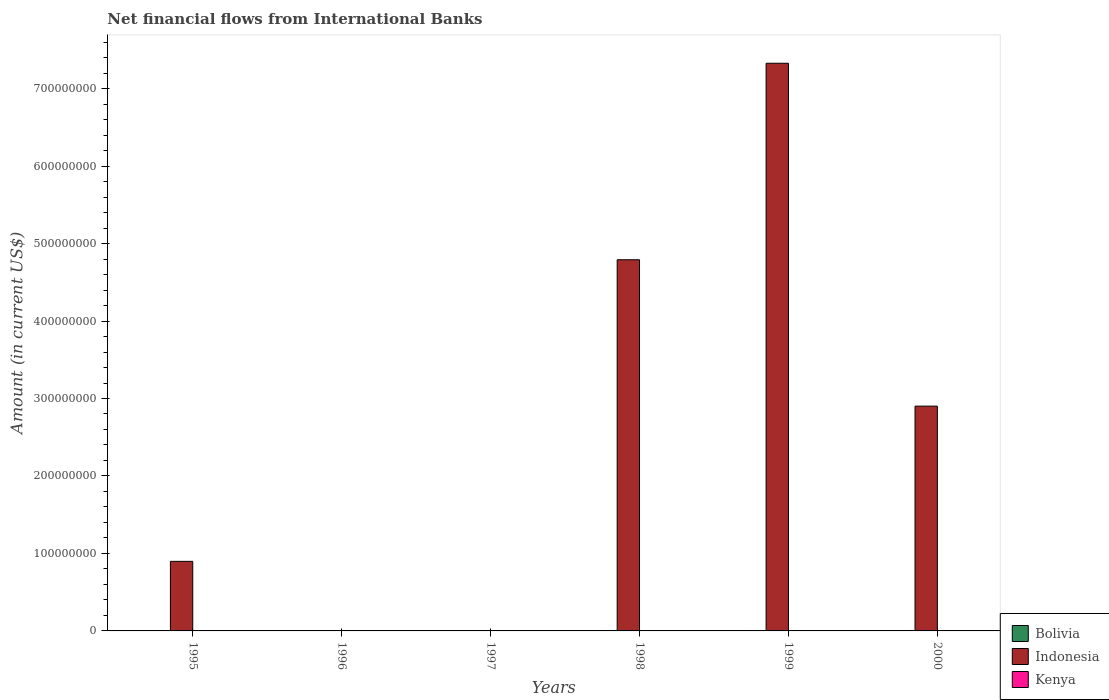How many different coloured bars are there?
Ensure brevity in your answer.  1. Are the number of bars on each tick of the X-axis equal?
Offer a very short reply. No. How many bars are there on the 5th tick from the left?
Your answer should be very brief. 1. How many bars are there on the 5th tick from the right?
Your answer should be compact. 0. Across all years, what is the maximum net financial aid flows in Indonesia?
Ensure brevity in your answer.  7.33e+08. In which year was the net financial aid flows in Indonesia maximum?
Your answer should be compact. 1999. What is the total net financial aid flows in Indonesia in the graph?
Make the answer very short. 1.59e+09. What is the difference between the net financial aid flows in Indonesia in 1998 and that in 1999?
Give a very brief answer. -2.54e+08. What is the difference between the net financial aid flows in Bolivia in 1999 and the net financial aid flows in Indonesia in 1995?
Provide a short and direct response. -8.98e+07. What is the average net financial aid flows in Indonesia per year?
Your response must be concise. 2.65e+08. In how many years, is the net financial aid flows in Indonesia greater than 540000000 US$?
Offer a very short reply. 1. What is the ratio of the net financial aid flows in Indonesia in 1995 to that in 2000?
Ensure brevity in your answer.  0.31. Is the net financial aid flows in Indonesia in 1998 less than that in 1999?
Keep it short and to the point. Yes. What is the difference between the highest and the second highest net financial aid flows in Indonesia?
Keep it short and to the point. 2.54e+08. What is the difference between the highest and the lowest net financial aid flows in Indonesia?
Ensure brevity in your answer.  7.33e+08. In how many years, is the net financial aid flows in Kenya greater than the average net financial aid flows in Kenya taken over all years?
Offer a terse response. 0. Are all the bars in the graph horizontal?
Provide a succinct answer. No. How many years are there in the graph?
Offer a very short reply. 6. Does the graph contain grids?
Ensure brevity in your answer.  No. What is the title of the graph?
Your answer should be compact. Net financial flows from International Banks. What is the label or title of the X-axis?
Your answer should be very brief. Years. What is the Amount (in current US$) in Indonesia in 1995?
Ensure brevity in your answer.  8.98e+07. What is the Amount (in current US$) of Kenya in 1995?
Provide a succinct answer. 0. What is the Amount (in current US$) of Bolivia in 1996?
Give a very brief answer. 0. What is the Amount (in current US$) of Indonesia in 1997?
Keep it short and to the point. 0. What is the Amount (in current US$) in Kenya in 1997?
Provide a short and direct response. 0. What is the Amount (in current US$) in Bolivia in 1998?
Offer a terse response. 0. What is the Amount (in current US$) of Indonesia in 1998?
Give a very brief answer. 4.79e+08. What is the Amount (in current US$) in Kenya in 1998?
Your answer should be very brief. 0. What is the Amount (in current US$) of Bolivia in 1999?
Give a very brief answer. 0. What is the Amount (in current US$) of Indonesia in 1999?
Your answer should be very brief. 7.33e+08. What is the Amount (in current US$) of Kenya in 1999?
Provide a succinct answer. 0. What is the Amount (in current US$) of Indonesia in 2000?
Your answer should be compact. 2.90e+08. What is the Amount (in current US$) in Kenya in 2000?
Keep it short and to the point. 0. Across all years, what is the maximum Amount (in current US$) in Indonesia?
Your response must be concise. 7.33e+08. What is the total Amount (in current US$) of Bolivia in the graph?
Give a very brief answer. 0. What is the total Amount (in current US$) of Indonesia in the graph?
Provide a short and direct response. 1.59e+09. What is the total Amount (in current US$) in Kenya in the graph?
Offer a terse response. 0. What is the difference between the Amount (in current US$) of Indonesia in 1995 and that in 1998?
Provide a succinct answer. -3.89e+08. What is the difference between the Amount (in current US$) of Indonesia in 1995 and that in 1999?
Offer a terse response. -6.43e+08. What is the difference between the Amount (in current US$) in Indonesia in 1995 and that in 2000?
Provide a short and direct response. -2.00e+08. What is the difference between the Amount (in current US$) in Indonesia in 1998 and that in 1999?
Your response must be concise. -2.54e+08. What is the difference between the Amount (in current US$) in Indonesia in 1998 and that in 2000?
Provide a short and direct response. 1.89e+08. What is the difference between the Amount (in current US$) of Indonesia in 1999 and that in 2000?
Your answer should be very brief. 4.43e+08. What is the average Amount (in current US$) in Indonesia per year?
Offer a very short reply. 2.65e+08. What is the ratio of the Amount (in current US$) of Indonesia in 1995 to that in 1998?
Keep it short and to the point. 0.19. What is the ratio of the Amount (in current US$) in Indonesia in 1995 to that in 1999?
Make the answer very short. 0.12. What is the ratio of the Amount (in current US$) of Indonesia in 1995 to that in 2000?
Your answer should be very brief. 0.31. What is the ratio of the Amount (in current US$) in Indonesia in 1998 to that in 1999?
Provide a succinct answer. 0.65. What is the ratio of the Amount (in current US$) in Indonesia in 1998 to that in 2000?
Provide a succinct answer. 1.65. What is the ratio of the Amount (in current US$) of Indonesia in 1999 to that in 2000?
Provide a short and direct response. 2.53. What is the difference between the highest and the second highest Amount (in current US$) in Indonesia?
Offer a very short reply. 2.54e+08. What is the difference between the highest and the lowest Amount (in current US$) of Indonesia?
Offer a terse response. 7.33e+08. 